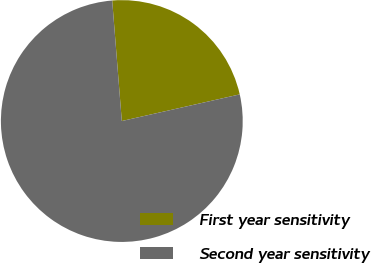<chart> <loc_0><loc_0><loc_500><loc_500><pie_chart><fcel>First year sensitivity<fcel>Second year sensitivity<nl><fcel>22.73%<fcel>77.27%<nl></chart> 